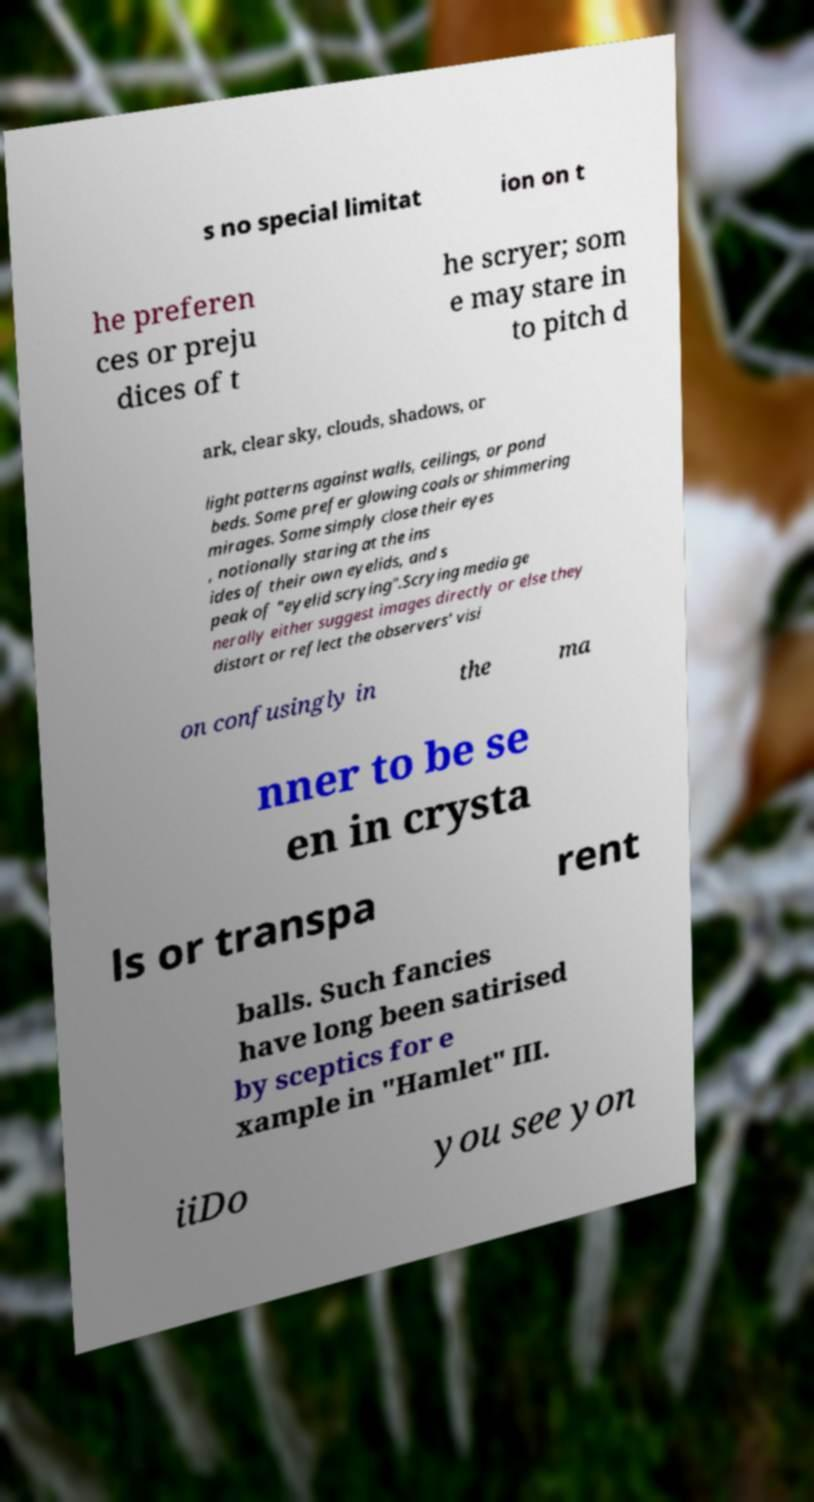Could you extract and type out the text from this image? s no special limitat ion on t he preferen ces or preju dices of t he scryer; som e may stare in to pitch d ark, clear sky, clouds, shadows, or light patterns against walls, ceilings, or pond beds. Some prefer glowing coals or shimmering mirages. Some simply close their eyes , notionally staring at the ins ides of their own eyelids, and s peak of "eyelid scrying".Scrying media ge nerally either suggest images directly or else they distort or reflect the observers' visi on confusingly in the ma nner to be se en in crysta ls or transpa rent balls. Such fancies have long been satirised by sceptics for e xample in "Hamlet" III. iiDo you see yon 